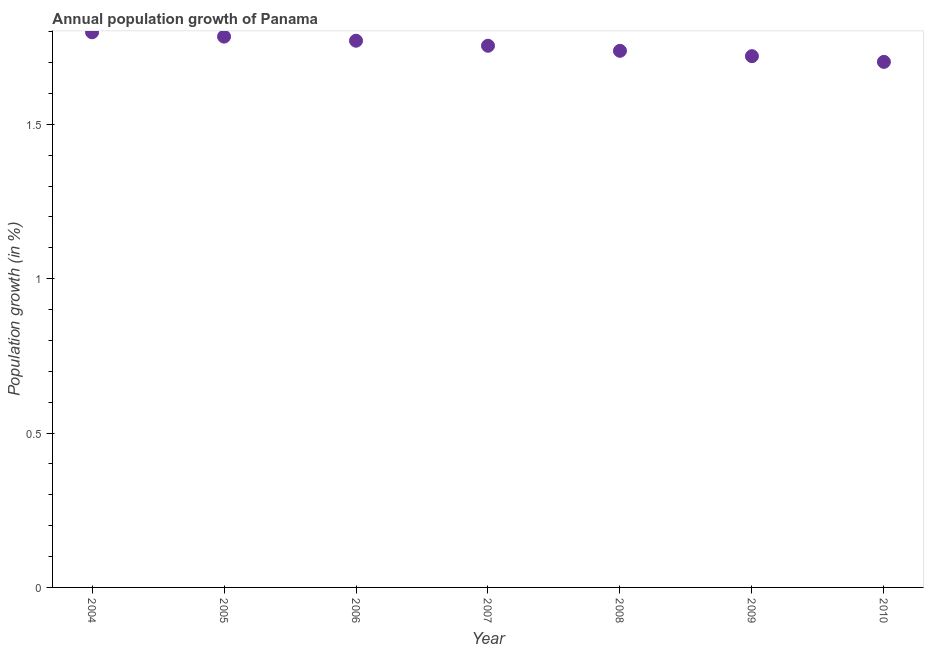What is the population growth in 2008?
Make the answer very short. 1.74. Across all years, what is the maximum population growth?
Your answer should be very brief. 1.8. Across all years, what is the minimum population growth?
Provide a short and direct response. 1.7. In which year was the population growth minimum?
Provide a short and direct response. 2010. What is the sum of the population growth?
Keep it short and to the point. 12.27. What is the difference between the population growth in 2006 and 2007?
Offer a terse response. 0.02. What is the average population growth per year?
Keep it short and to the point. 1.75. What is the median population growth?
Give a very brief answer. 1.75. Do a majority of the years between 2007 and 2004 (inclusive) have population growth greater than 1.6 %?
Keep it short and to the point. Yes. What is the ratio of the population growth in 2007 to that in 2009?
Ensure brevity in your answer.  1.02. Is the population growth in 2007 less than that in 2010?
Give a very brief answer. No. Is the difference between the population growth in 2005 and 2009 greater than the difference between any two years?
Ensure brevity in your answer.  No. What is the difference between the highest and the second highest population growth?
Give a very brief answer. 0.01. Is the sum of the population growth in 2007 and 2009 greater than the maximum population growth across all years?
Ensure brevity in your answer.  Yes. What is the difference between the highest and the lowest population growth?
Your response must be concise. 0.1. Does the population growth monotonically increase over the years?
Your response must be concise. No. How many years are there in the graph?
Make the answer very short. 7. What is the difference between two consecutive major ticks on the Y-axis?
Offer a very short reply. 0.5. Does the graph contain any zero values?
Provide a succinct answer. No. What is the title of the graph?
Keep it short and to the point. Annual population growth of Panama. What is the label or title of the Y-axis?
Offer a terse response. Population growth (in %). What is the Population growth (in %) in 2004?
Your answer should be very brief. 1.8. What is the Population growth (in %) in 2005?
Make the answer very short. 1.78. What is the Population growth (in %) in 2006?
Give a very brief answer. 1.77. What is the Population growth (in %) in 2007?
Provide a short and direct response. 1.75. What is the Population growth (in %) in 2008?
Offer a very short reply. 1.74. What is the Population growth (in %) in 2009?
Your answer should be compact. 1.72. What is the Population growth (in %) in 2010?
Your answer should be very brief. 1.7. What is the difference between the Population growth (in %) in 2004 and 2005?
Make the answer very short. 0.01. What is the difference between the Population growth (in %) in 2004 and 2006?
Keep it short and to the point. 0.03. What is the difference between the Population growth (in %) in 2004 and 2007?
Ensure brevity in your answer.  0.04. What is the difference between the Population growth (in %) in 2004 and 2008?
Provide a succinct answer. 0.06. What is the difference between the Population growth (in %) in 2004 and 2009?
Your answer should be compact. 0.08. What is the difference between the Population growth (in %) in 2004 and 2010?
Ensure brevity in your answer.  0.1. What is the difference between the Population growth (in %) in 2005 and 2006?
Offer a terse response. 0.01. What is the difference between the Population growth (in %) in 2005 and 2007?
Offer a terse response. 0.03. What is the difference between the Population growth (in %) in 2005 and 2008?
Provide a succinct answer. 0.05. What is the difference between the Population growth (in %) in 2005 and 2009?
Your answer should be compact. 0.06. What is the difference between the Population growth (in %) in 2005 and 2010?
Offer a terse response. 0.08. What is the difference between the Population growth (in %) in 2006 and 2007?
Provide a succinct answer. 0.02. What is the difference between the Population growth (in %) in 2006 and 2008?
Provide a short and direct response. 0.03. What is the difference between the Population growth (in %) in 2006 and 2009?
Make the answer very short. 0.05. What is the difference between the Population growth (in %) in 2006 and 2010?
Provide a succinct answer. 0.07. What is the difference between the Population growth (in %) in 2007 and 2008?
Offer a very short reply. 0.02. What is the difference between the Population growth (in %) in 2007 and 2009?
Keep it short and to the point. 0.03. What is the difference between the Population growth (in %) in 2007 and 2010?
Provide a short and direct response. 0.05. What is the difference between the Population growth (in %) in 2008 and 2009?
Keep it short and to the point. 0.02. What is the difference between the Population growth (in %) in 2008 and 2010?
Keep it short and to the point. 0.04. What is the difference between the Population growth (in %) in 2009 and 2010?
Provide a succinct answer. 0.02. What is the ratio of the Population growth (in %) in 2004 to that in 2005?
Your response must be concise. 1.01. What is the ratio of the Population growth (in %) in 2004 to that in 2006?
Provide a short and direct response. 1.01. What is the ratio of the Population growth (in %) in 2004 to that in 2007?
Give a very brief answer. 1.02. What is the ratio of the Population growth (in %) in 2004 to that in 2008?
Ensure brevity in your answer.  1.03. What is the ratio of the Population growth (in %) in 2004 to that in 2009?
Offer a terse response. 1.04. What is the ratio of the Population growth (in %) in 2004 to that in 2010?
Your answer should be very brief. 1.06. What is the ratio of the Population growth (in %) in 2005 to that in 2006?
Your answer should be very brief. 1.01. What is the ratio of the Population growth (in %) in 2005 to that in 2008?
Provide a short and direct response. 1.03. What is the ratio of the Population growth (in %) in 2005 to that in 2010?
Provide a succinct answer. 1.05. What is the ratio of the Population growth (in %) in 2006 to that in 2007?
Provide a short and direct response. 1.01. What is the ratio of the Population growth (in %) in 2006 to that in 2009?
Keep it short and to the point. 1.03. What is the ratio of the Population growth (in %) in 2006 to that in 2010?
Ensure brevity in your answer.  1.04. What is the ratio of the Population growth (in %) in 2007 to that in 2009?
Offer a very short reply. 1.02. What is the ratio of the Population growth (in %) in 2007 to that in 2010?
Make the answer very short. 1.03. What is the ratio of the Population growth (in %) in 2008 to that in 2009?
Your answer should be very brief. 1.01. What is the ratio of the Population growth (in %) in 2008 to that in 2010?
Your answer should be compact. 1.02. 